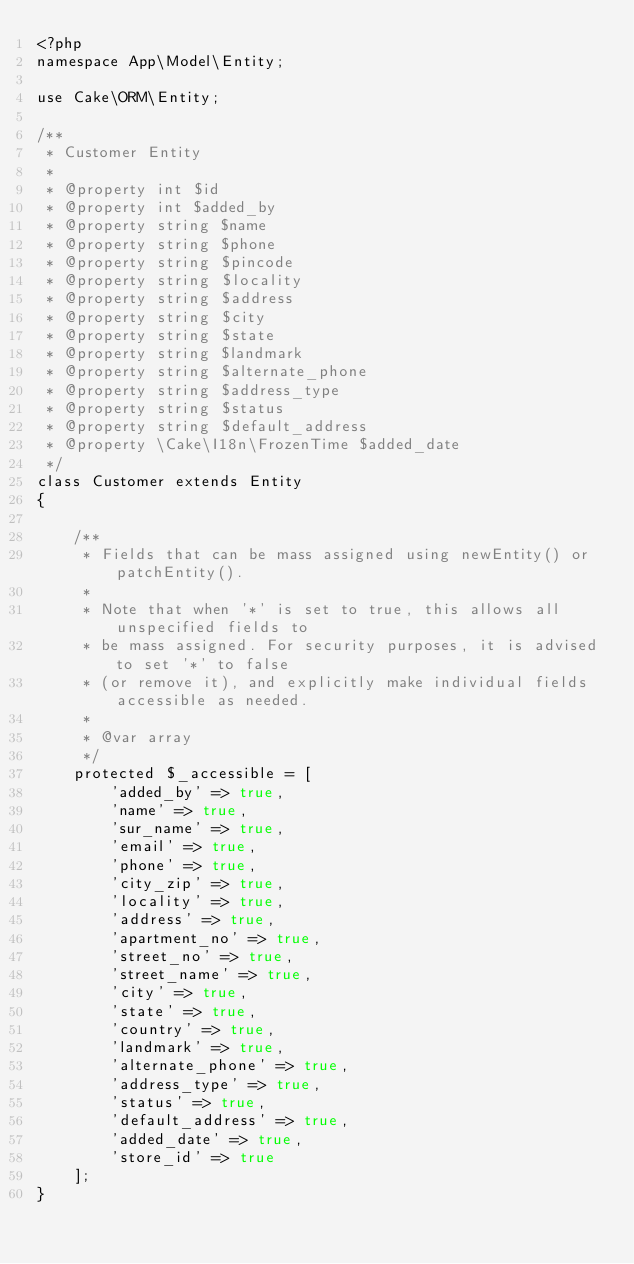<code> <loc_0><loc_0><loc_500><loc_500><_PHP_><?php
namespace App\Model\Entity;

use Cake\ORM\Entity;

/**
 * Customer Entity
 *
 * @property int $id
 * @property int $added_by
 * @property string $name
 * @property string $phone
 * @property string $pincode
 * @property string $locality
 * @property string $address
 * @property string $city
 * @property string $state
 * @property string $landmark
 * @property string $alternate_phone
 * @property string $address_type
 * @property string $status
 * @property string $default_address
 * @property \Cake\I18n\FrozenTime $added_date
 */
class Customer extends Entity
{

    /**
     * Fields that can be mass assigned using newEntity() or patchEntity().
     *
     * Note that when '*' is set to true, this allows all unspecified fields to
     * be mass assigned. For security purposes, it is advised to set '*' to false
     * (or remove it), and explicitly make individual fields accessible as needed.
     *
     * @var array
     */
    protected $_accessible = [
        'added_by' => true,
        'name' => true,
		'sur_name' => true,
		'email' => true,
        'phone' => true,
        'city_zip' => true,
        'locality' => true,
        'address' => true,
        'apartment_no' => true,
        'street_no' => true,
        'street_name' => true,
        'city' => true,
        'state' => true,
		'country' => true,
        'landmark' => true,
        'alternate_phone' => true,
        'address_type' => true,
        'status' => true,
        'default_address' => true,
        'added_date' => true,
        'store_id' => true
    ];
}
</code> 